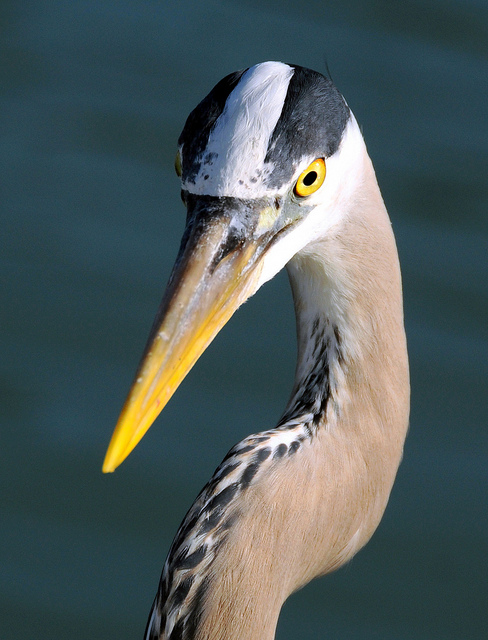<image>What type of bird is this? I don't know what type of bird this is. It can be egret, swan, pelican, stork, geese, or heron. What type of bird is this? I don't know what type of bird it is. It can be egret, swan, pelican, stork, geese, heron, or pelican. 